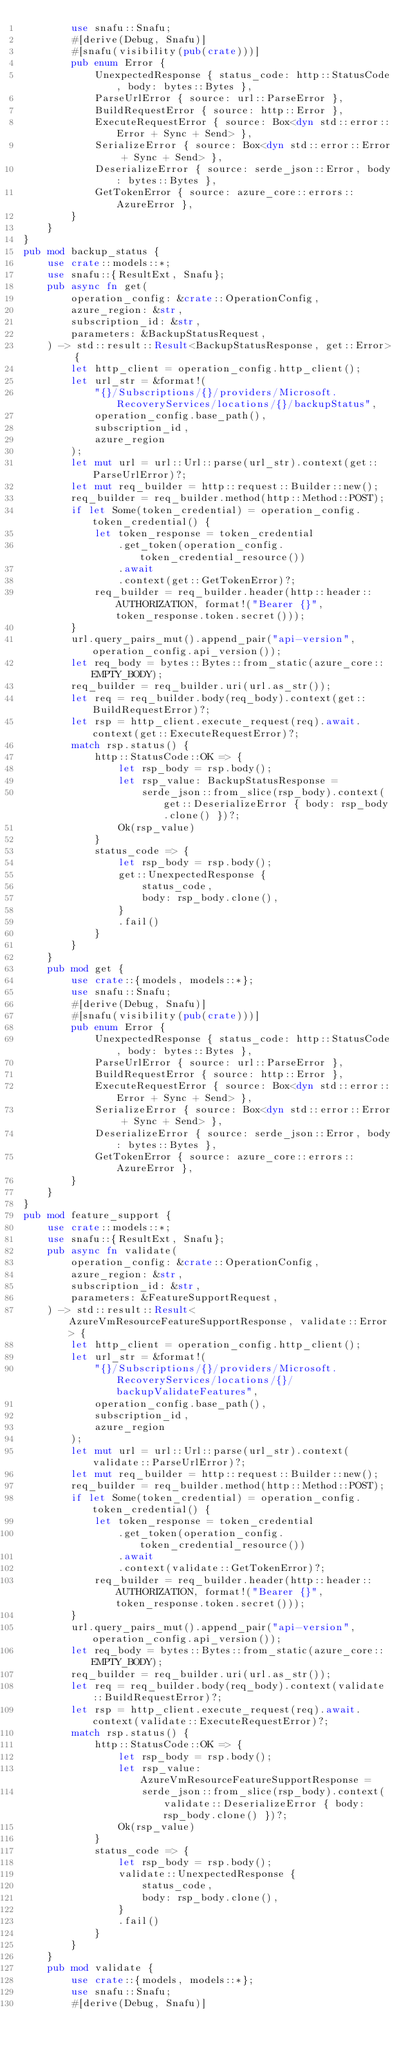<code> <loc_0><loc_0><loc_500><loc_500><_Rust_>        use snafu::Snafu;
        #[derive(Debug, Snafu)]
        #[snafu(visibility(pub(crate)))]
        pub enum Error {
            UnexpectedResponse { status_code: http::StatusCode, body: bytes::Bytes },
            ParseUrlError { source: url::ParseError },
            BuildRequestError { source: http::Error },
            ExecuteRequestError { source: Box<dyn std::error::Error + Sync + Send> },
            SerializeError { source: Box<dyn std::error::Error + Sync + Send> },
            DeserializeError { source: serde_json::Error, body: bytes::Bytes },
            GetTokenError { source: azure_core::errors::AzureError },
        }
    }
}
pub mod backup_status {
    use crate::models::*;
    use snafu::{ResultExt, Snafu};
    pub async fn get(
        operation_config: &crate::OperationConfig,
        azure_region: &str,
        subscription_id: &str,
        parameters: &BackupStatusRequest,
    ) -> std::result::Result<BackupStatusResponse, get::Error> {
        let http_client = operation_config.http_client();
        let url_str = &format!(
            "{}/Subscriptions/{}/providers/Microsoft.RecoveryServices/locations/{}/backupStatus",
            operation_config.base_path(),
            subscription_id,
            azure_region
        );
        let mut url = url::Url::parse(url_str).context(get::ParseUrlError)?;
        let mut req_builder = http::request::Builder::new();
        req_builder = req_builder.method(http::Method::POST);
        if let Some(token_credential) = operation_config.token_credential() {
            let token_response = token_credential
                .get_token(operation_config.token_credential_resource())
                .await
                .context(get::GetTokenError)?;
            req_builder = req_builder.header(http::header::AUTHORIZATION, format!("Bearer {}", token_response.token.secret()));
        }
        url.query_pairs_mut().append_pair("api-version", operation_config.api_version());
        let req_body = bytes::Bytes::from_static(azure_core::EMPTY_BODY);
        req_builder = req_builder.uri(url.as_str());
        let req = req_builder.body(req_body).context(get::BuildRequestError)?;
        let rsp = http_client.execute_request(req).await.context(get::ExecuteRequestError)?;
        match rsp.status() {
            http::StatusCode::OK => {
                let rsp_body = rsp.body();
                let rsp_value: BackupStatusResponse =
                    serde_json::from_slice(rsp_body).context(get::DeserializeError { body: rsp_body.clone() })?;
                Ok(rsp_value)
            }
            status_code => {
                let rsp_body = rsp.body();
                get::UnexpectedResponse {
                    status_code,
                    body: rsp_body.clone(),
                }
                .fail()
            }
        }
    }
    pub mod get {
        use crate::{models, models::*};
        use snafu::Snafu;
        #[derive(Debug, Snafu)]
        #[snafu(visibility(pub(crate)))]
        pub enum Error {
            UnexpectedResponse { status_code: http::StatusCode, body: bytes::Bytes },
            ParseUrlError { source: url::ParseError },
            BuildRequestError { source: http::Error },
            ExecuteRequestError { source: Box<dyn std::error::Error + Sync + Send> },
            SerializeError { source: Box<dyn std::error::Error + Sync + Send> },
            DeserializeError { source: serde_json::Error, body: bytes::Bytes },
            GetTokenError { source: azure_core::errors::AzureError },
        }
    }
}
pub mod feature_support {
    use crate::models::*;
    use snafu::{ResultExt, Snafu};
    pub async fn validate(
        operation_config: &crate::OperationConfig,
        azure_region: &str,
        subscription_id: &str,
        parameters: &FeatureSupportRequest,
    ) -> std::result::Result<AzureVmResourceFeatureSupportResponse, validate::Error> {
        let http_client = operation_config.http_client();
        let url_str = &format!(
            "{}/Subscriptions/{}/providers/Microsoft.RecoveryServices/locations/{}/backupValidateFeatures",
            operation_config.base_path(),
            subscription_id,
            azure_region
        );
        let mut url = url::Url::parse(url_str).context(validate::ParseUrlError)?;
        let mut req_builder = http::request::Builder::new();
        req_builder = req_builder.method(http::Method::POST);
        if let Some(token_credential) = operation_config.token_credential() {
            let token_response = token_credential
                .get_token(operation_config.token_credential_resource())
                .await
                .context(validate::GetTokenError)?;
            req_builder = req_builder.header(http::header::AUTHORIZATION, format!("Bearer {}", token_response.token.secret()));
        }
        url.query_pairs_mut().append_pair("api-version", operation_config.api_version());
        let req_body = bytes::Bytes::from_static(azure_core::EMPTY_BODY);
        req_builder = req_builder.uri(url.as_str());
        let req = req_builder.body(req_body).context(validate::BuildRequestError)?;
        let rsp = http_client.execute_request(req).await.context(validate::ExecuteRequestError)?;
        match rsp.status() {
            http::StatusCode::OK => {
                let rsp_body = rsp.body();
                let rsp_value: AzureVmResourceFeatureSupportResponse =
                    serde_json::from_slice(rsp_body).context(validate::DeserializeError { body: rsp_body.clone() })?;
                Ok(rsp_value)
            }
            status_code => {
                let rsp_body = rsp.body();
                validate::UnexpectedResponse {
                    status_code,
                    body: rsp_body.clone(),
                }
                .fail()
            }
        }
    }
    pub mod validate {
        use crate::{models, models::*};
        use snafu::Snafu;
        #[derive(Debug, Snafu)]</code> 